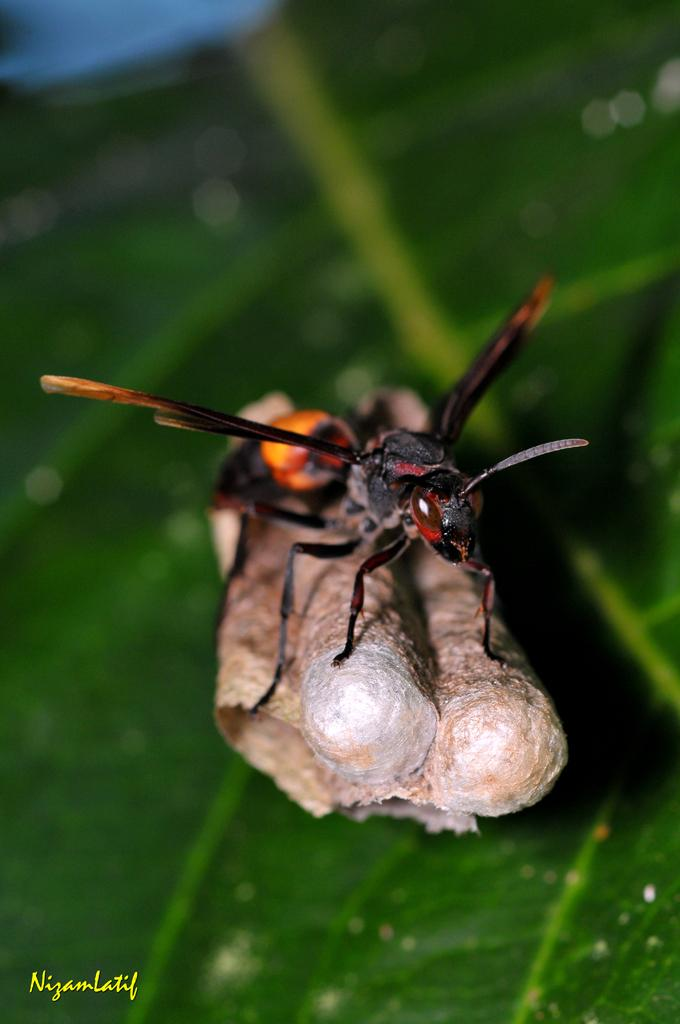What type of creature can be seen in the image? There is an insect in the image. What is the insect standing on? The insect is standing on an object. What is visible below the insect? There is a green leaf below the insect. Where can we find text in the image? There is text written in the left bottom corner of the image. What type of honey can be seen dripping from the button in the image? There is no button or honey present in the image. 